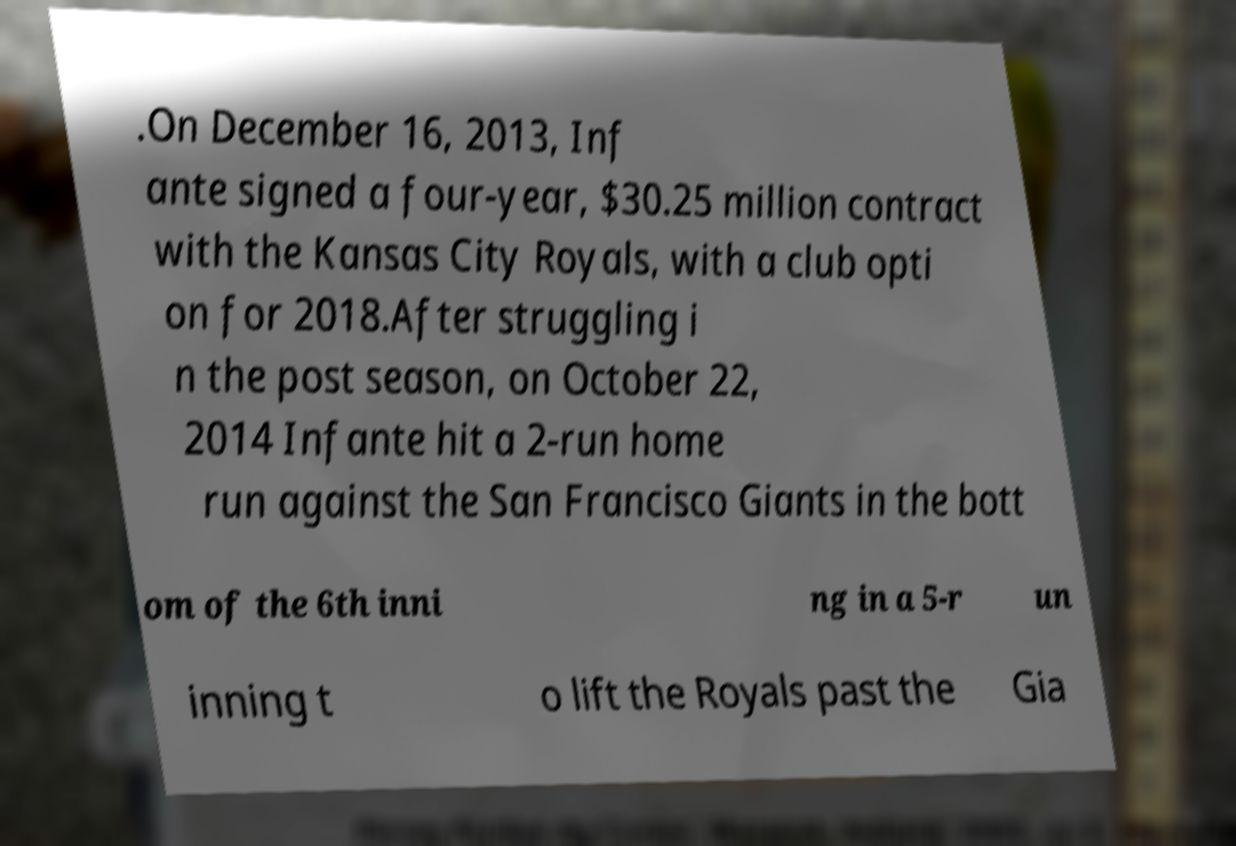There's text embedded in this image that I need extracted. Can you transcribe it verbatim? .On December 16, 2013, Inf ante signed a four-year, $30.25 million contract with the Kansas City Royals, with a club opti on for 2018.After struggling i n the post season, on October 22, 2014 Infante hit a 2-run home run against the San Francisco Giants in the bott om of the 6th inni ng in a 5-r un inning t o lift the Royals past the Gia 